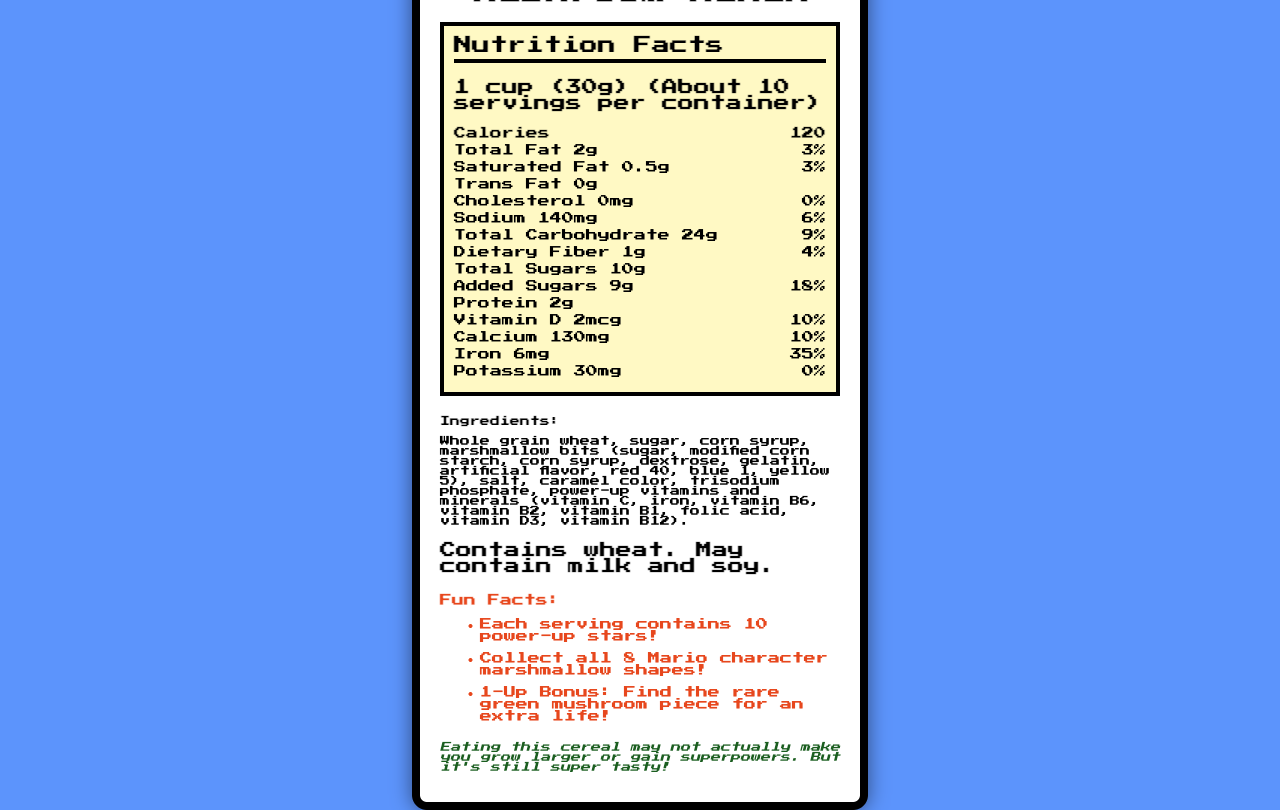what is the serving size for Super Mario Mushroom Munch? The serving size is explicitly mentioned in the Nutrition Facts section.
Answer: 1 cup (30g) how many servings per container are there? The number of servings per container is specified right after the serving size information.
Answer: About 10 how many total calories are in one serving? The total calories for one serving are clearly listed under the Calories section.
Answer: 120 how much sodium does one serving contain? The sodium content per serving is listed in the Sodium section.
Answer: 140mg what is the daily value percentage for iron? The daily value percentage for iron is listed in the Iron section.
Answer: 35% how many grams of total sugars are in one serving? This information is provided in the Total Sugars section.
Answer: 10g what is the total amount of dietary fiber in one serving? The amount of dietary fiber is detailed in the Dietary Fiber section.
Answer: 1g what is the main ingredient in Super Mario Mushroom Munch? A. Sugar B. Corn syrup C. Whole grain wheat The main ingredient is listed at the beginning of the Ingredients section, which is Whole grain wheat.
Answer: C which vitamin content provides the highest daily value percentage? A. Vitamin D B. Calcium C. Iron D. Vitamin B6 Comparing all the vitamins' daily value percentages, Iron has the highest at 35%.
Answer: C does this cereal contain any trans fat? The Trans Fat section explicitly states that it contains 0g of trans fat.
Answer: No is there any cholesterol in Super Mario Mushroom Munch? The Cholesterol section specifies that it contains 0mg of cholesterol.
Answer: No what is the main idea of this document? The document aims to inform consumers about the nutritional content and ingredients of the breakfast cereal while tying in playful and thematic elements from the Super Mario series.
Answer: The document provides detailed nutritional information for Super Mario Mushroom Munch, including serving size, calories, macronutrients, vitamins, and ingredients. Additionally, it highlights fun facts about the cereal related to the Super Mario video game franchise. what kind of flavoring is used in the marshmallow bits? The flavoring is listed among the ingredients for the marshmallow bits.
Answer: Artificial flavor can eating this cereal actually make you grow larger or gain superpowers? A note in the game reference section humorously mentions that consuming the cereal won't actually make you grow larger or gain superpowers.
Answer: No how many grams of added sugars are there in one serving? The amount of added sugars is listed in the Added Sugars section.
Answer: 9g does the document specify the amount of vitamin C in the cereal? The document does not provide specific quantitative information on the vitamin C content; it only mentions that it contains "power-up vitamins and minerals" which include vitamin C.
Answer: Not enough information 